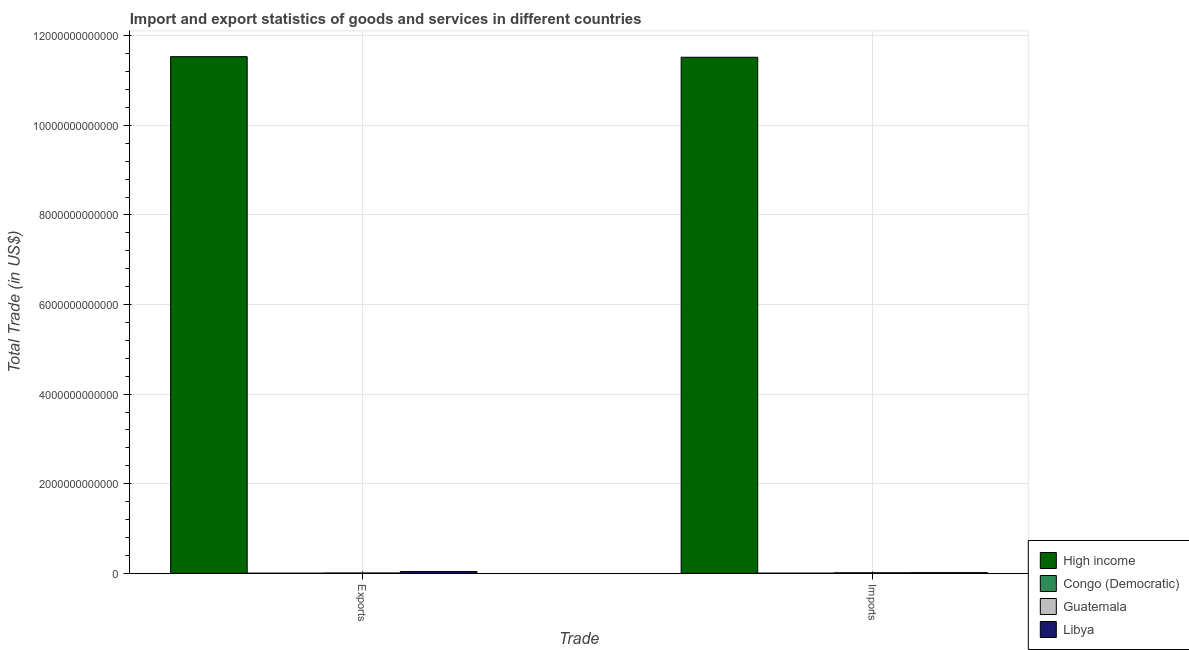How many different coloured bars are there?
Make the answer very short. 4. How many groups of bars are there?
Your response must be concise. 2. Are the number of bars per tick equal to the number of legend labels?
Keep it short and to the point. Yes. Are the number of bars on each tick of the X-axis equal?
Offer a terse response. Yes. What is the label of the 1st group of bars from the left?
Make the answer very short. Exports. What is the imports of goods and services in Guatemala?
Provide a short and direct response. 1.27e+1. Across all countries, what is the maximum imports of goods and services?
Provide a succinct answer. 1.15e+13. Across all countries, what is the minimum export of goods and services?
Provide a short and direct response. 2.77e+09. In which country was the export of goods and services minimum?
Your answer should be compact. Congo (Democratic). What is the total export of goods and services in the graph?
Your answer should be very brief. 1.16e+13. What is the difference between the imports of goods and services in Guatemala and that in Libya?
Provide a short and direct response. -2.89e+09. What is the difference between the imports of goods and services in Libya and the export of goods and services in Congo (Democratic)?
Provide a short and direct response. 1.28e+1. What is the average export of goods and services per country?
Provide a short and direct response. 2.90e+12. What is the difference between the export of goods and services and imports of goods and services in Libya?
Ensure brevity in your answer.  2.49e+1. What is the ratio of the imports of goods and services in Congo (Democratic) to that in High income?
Keep it short and to the point. 0. In how many countries, is the export of goods and services greater than the average export of goods and services taken over all countries?
Ensure brevity in your answer.  1. What does the 1st bar from the left in Exports represents?
Offer a very short reply. High income. What does the 1st bar from the right in Imports represents?
Ensure brevity in your answer.  Libya. How many countries are there in the graph?
Give a very brief answer. 4. What is the difference between two consecutive major ticks on the Y-axis?
Provide a short and direct response. 2.00e+12. Does the graph contain any zero values?
Your response must be concise. No. Where does the legend appear in the graph?
Provide a short and direct response. Bottom right. What is the title of the graph?
Offer a terse response. Import and export statistics of goods and services in different countries. What is the label or title of the X-axis?
Offer a terse response. Trade. What is the label or title of the Y-axis?
Give a very brief answer. Total Trade (in US$). What is the Total Trade (in US$) of High income in Exports?
Your answer should be very brief. 1.15e+13. What is the Total Trade (in US$) of Congo (Democratic) in Exports?
Keep it short and to the point. 2.77e+09. What is the Total Trade (in US$) in Guatemala in Exports?
Provide a succinct answer. 7.54e+09. What is the Total Trade (in US$) of Libya in Exports?
Your answer should be very brief. 4.04e+1. What is the Total Trade (in US$) of High income in Imports?
Make the answer very short. 1.15e+13. What is the Total Trade (in US$) in Congo (Democratic) in Imports?
Give a very brief answer. 3.62e+09. What is the Total Trade (in US$) in Guatemala in Imports?
Offer a terse response. 1.27e+1. What is the Total Trade (in US$) in Libya in Imports?
Give a very brief answer. 1.56e+1. Across all Trade, what is the maximum Total Trade (in US$) in High income?
Give a very brief answer. 1.15e+13. Across all Trade, what is the maximum Total Trade (in US$) of Congo (Democratic)?
Offer a very short reply. 3.62e+09. Across all Trade, what is the maximum Total Trade (in US$) in Guatemala?
Ensure brevity in your answer.  1.27e+1. Across all Trade, what is the maximum Total Trade (in US$) in Libya?
Your answer should be compact. 4.04e+1. Across all Trade, what is the minimum Total Trade (in US$) of High income?
Your answer should be compact. 1.15e+13. Across all Trade, what is the minimum Total Trade (in US$) of Congo (Democratic)?
Offer a very short reply. 2.77e+09. Across all Trade, what is the minimum Total Trade (in US$) in Guatemala?
Your response must be concise. 7.54e+09. Across all Trade, what is the minimum Total Trade (in US$) in Libya?
Offer a very short reply. 1.56e+1. What is the total Total Trade (in US$) in High income in the graph?
Ensure brevity in your answer.  2.31e+13. What is the total Total Trade (in US$) in Congo (Democratic) in the graph?
Your answer should be very brief. 6.39e+09. What is the total Total Trade (in US$) of Guatemala in the graph?
Give a very brief answer. 2.02e+1. What is the total Total Trade (in US$) in Libya in the graph?
Keep it short and to the point. 5.60e+1. What is the difference between the Total Trade (in US$) in High income in Exports and that in Imports?
Give a very brief answer. 1.32e+1. What is the difference between the Total Trade (in US$) in Congo (Democratic) in Exports and that in Imports?
Ensure brevity in your answer.  -8.55e+08. What is the difference between the Total Trade (in US$) in Guatemala in Exports and that in Imports?
Your answer should be very brief. -5.13e+09. What is the difference between the Total Trade (in US$) in Libya in Exports and that in Imports?
Offer a very short reply. 2.49e+1. What is the difference between the Total Trade (in US$) of High income in Exports and the Total Trade (in US$) of Congo (Democratic) in Imports?
Offer a very short reply. 1.15e+13. What is the difference between the Total Trade (in US$) of High income in Exports and the Total Trade (in US$) of Guatemala in Imports?
Ensure brevity in your answer.  1.15e+13. What is the difference between the Total Trade (in US$) of High income in Exports and the Total Trade (in US$) of Libya in Imports?
Offer a very short reply. 1.15e+13. What is the difference between the Total Trade (in US$) of Congo (Democratic) in Exports and the Total Trade (in US$) of Guatemala in Imports?
Your answer should be very brief. -9.90e+09. What is the difference between the Total Trade (in US$) of Congo (Democratic) in Exports and the Total Trade (in US$) of Libya in Imports?
Offer a terse response. -1.28e+1. What is the difference between the Total Trade (in US$) of Guatemala in Exports and the Total Trade (in US$) of Libya in Imports?
Provide a succinct answer. -8.02e+09. What is the average Total Trade (in US$) in High income per Trade?
Your answer should be compact. 1.15e+13. What is the average Total Trade (in US$) of Congo (Democratic) per Trade?
Give a very brief answer. 3.19e+09. What is the average Total Trade (in US$) of Guatemala per Trade?
Give a very brief answer. 1.01e+1. What is the average Total Trade (in US$) in Libya per Trade?
Make the answer very short. 2.80e+1. What is the difference between the Total Trade (in US$) in High income and Total Trade (in US$) in Congo (Democratic) in Exports?
Provide a short and direct response. 1.15e+13. What is the difference between the Total Trade (in US$) in High income and Total Trade (in US$) in Guatemala in Exports?
Offer a terse response. 1.15e+13. What is the difference between the Total Trade (in US$) of High income and Total Trade (in US$) of Libya in Exports?
Keep it short and to the point. 1.15e+13. What is the difference between the Total Trade (in US$) of Congo (Democratic) and Total Trade (in US$) of Guatemala in Exports?
Your answer should be compact. -4.77e+09. What is the difference between the Total Trade (in US$) in Congo (Democratic) and Total Trade (in US$) in Libya in Exports?
Your answer should be very brief. -3.77e+1. What is the difference between the Total Trade (in US$) in Guatemala and Total Trade (in US$) in Libya in Exports?
Your answer should be very brief. -3.29e+1. What is the difference between the Total Trade (in US$) of High income and Total Trade (in US$) of Congo (Democratic) in Imports?
Your answer should be compact. 1.15e+13. What is the difference between the Total Trade (in US$) of High income and Total Trade (in US$) of Guatemala in Imports?
Make the answer very short. 1.15e+13. What is the difference between the Total Trade (in US$) in High income and Total Trade (in US$) in Libya in Imports?
Provide a succinct answer. 1.15e+13. What is the difference between the Total Trade (in US$) of Congo (Democratic) and Total Trade (in US$) of Guatemala in Imports?
Your response must be concise. -9.04e+09. What is the difference between the Total Trade (in US$) of Congo (Democratic) and Total Trade (in US$) of Libya in Imports?
Your answer should be very brief. -1.19e+1. What is the difference between the Total Trade (in US$) of Guatemala and Total Trade (in US$) of Libya in Imports?
Your answer should be compact. -2.89e+09. What is the ratio of the Total Trade (in US$) of Congo (Democratic) in Exports to that in Imports?
Give a very brief answer. 0.76. What is the ratio of the Total Trade (in US$) in Guatemala in Exports to that in Imports?
Give a very brief answer. 0.6. What is the ratio of the Total Trade (in US$) in Libya in Exports to that in Imports?
Offer a terse response. 2.6. What is the difference between the highest and the second highest Total Trade (in US$) in High income?
Ensure brevity in your answer.  1.32e+1. What is the difference between the highest and the second highest Total Trade (in US$) of Congo (Democratic)?
Your answer should be compact. 8.55e+08. What is the difference between the highest and the second highest Total Trade (in US$) in Guatemala?
Your answer should be very brief. 5.13e+09. What is the difference between the highest and the second highest Total Trade (in US$) in Libya?
Your response must be concise. 2.49e+1. What is the difference between the highest and the lowest Total Trade (in US$) in High income?
Your answer should be very brief. 1.32e+1. What is the difference between the highest and the lowest Total Trade (in US$) of Congo (Democratic)?
Make the answer very short. 8.55e+08. What is the difference between the highest and the lowest Total Trade (in US$) of Guatemala?
Provide a succinct answer. 5.13e+09. What is the difference between the highest and the lowest Total Trade (in US$) of Libya?
Provide a succinct answer. 2.49e+1. 